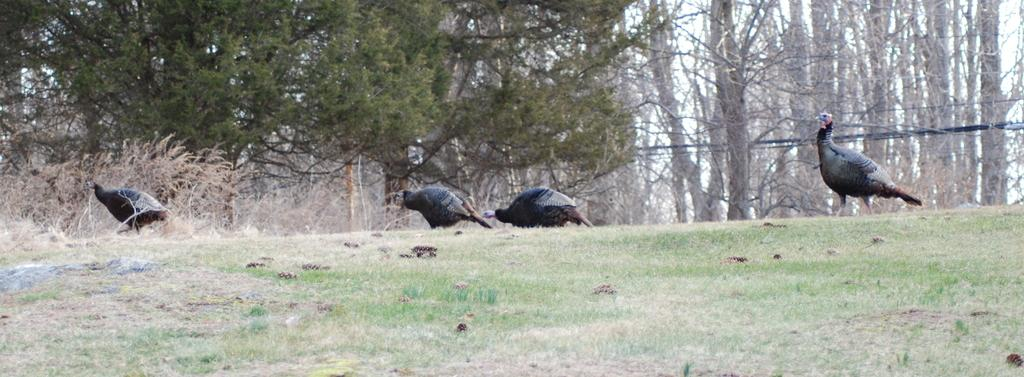How many birds are present in the image? There are four birds in the image. What are the birds doing in the image? The birds are standing. What type of vegetation can be seen in the image? There is grass in the image. What else can be seen in the image besides the birds and grass? There are trees with branches and leaves in the image. What time of day is it in the image, considering the presence of the library? There is no library present in the image, so it is not possible to determine the time of day based on that information. 